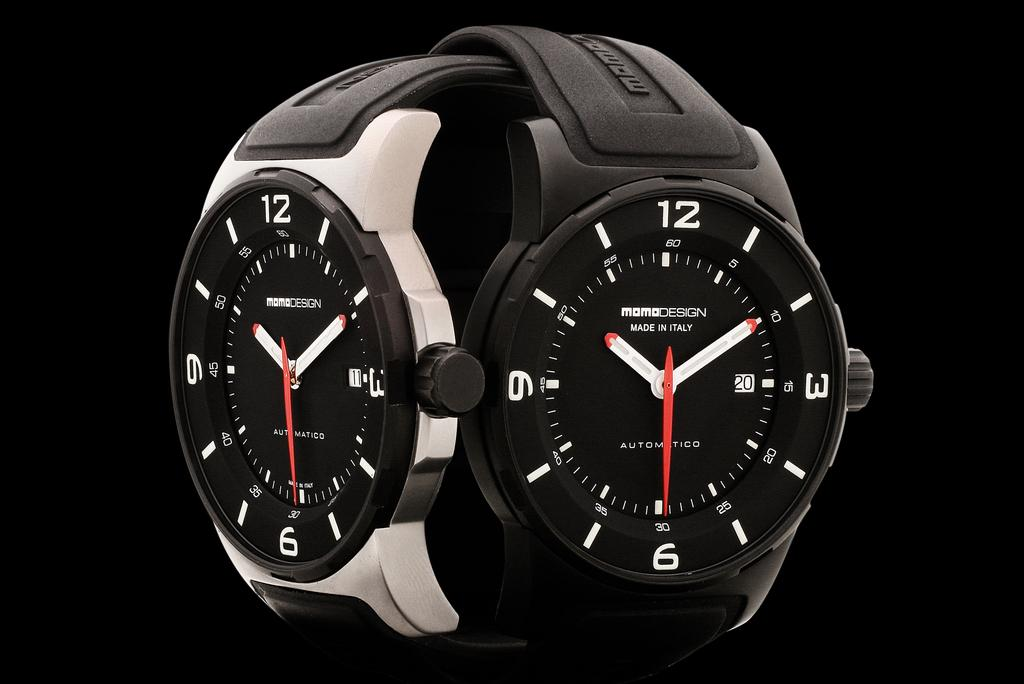<image>
Offer a succinct explanation of the picture presented. Two MomoDesign watches sit with their bands intertwined. 